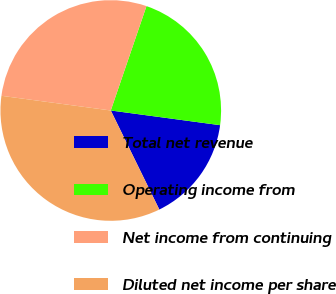<chart> <loc_0><loc_0><loc_500><loc_500><pie_chart><fcel>Total net revenue<fcel>Operating income from<fcel>Net income from continuing<fcel>Diluted net income per share<nl><fcel>15.62%<fcel>21.88%<fcel>28.12%<fcel>34.38%<nl></chart> 